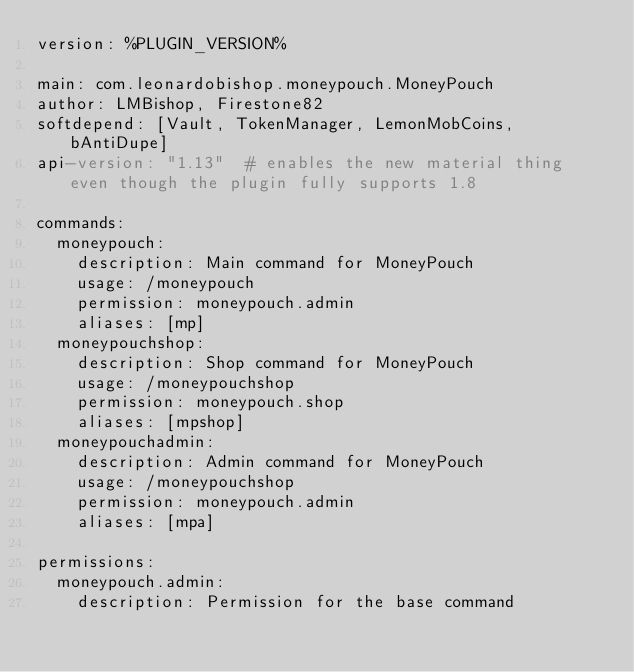<code> <loc_0><loc_0><loc_500><loc_500><_YAML_>version: %PLUGIN_VERSION%

main: com.leonardobishop.moneypouch.MoneyPouch
author: LMBishop, Firestone82
softdepend: [Vault, TokenManager, LemonMobCoins, bAntiDupe]
api-version: "1.13"  # enables the new material thing even though the plugin fully supports 1.8

commands:
  moneypouch:
    description: Main command for MoneyPouch
    usage: /moneypouch
    permission: moneypouch.admin
    aliases: [mp]
  moneypouchshop:
    description: Shop command for MoneyPouch
    usage: /moneypouchshop
    permission: moneypouch.shop
    aliases: [mpshop]
  moneypouchadmin:
    description: Admin command for MoneyPouch
    usage: /moneypouchshop
    permission: moneypouch.admin
    aliases: [mpa]

permissions:
  moneypouch.admin:
    description: Permission for the base command
</code> 